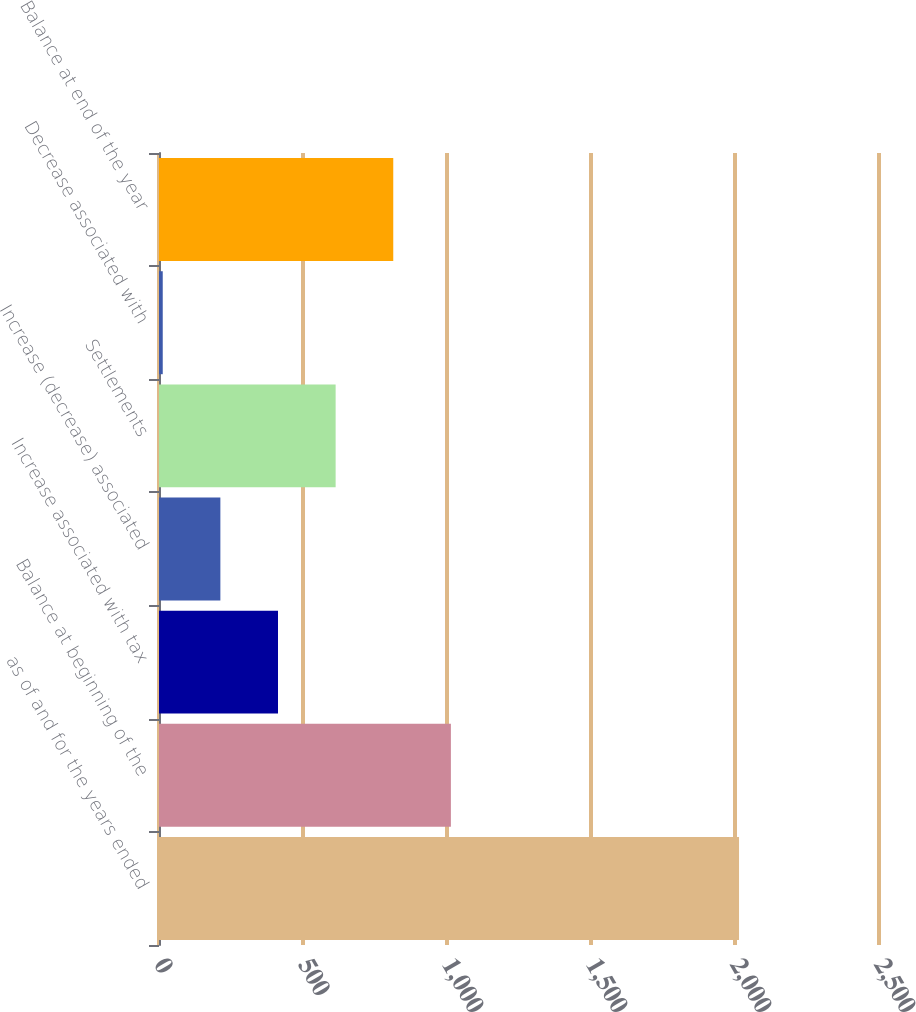Convert chart to OTSL. <chart><loc_0><loc_0><loc_500><loc_500><bar_chart><fcel>as of and for the years ended<fcel>Balance at beginning of the<fcel>Increase associated with tax<fcel>Increase (decrease) associated<fcel>Settlements<fcel>Decrease associated with<fcel>Balance at end of the year<nl><fcel>2014<fcel>1013.5<fcel>413.2<fcel>213.1<fcel>613.3<fcel>13<fcel>813.4<nl></chart> 